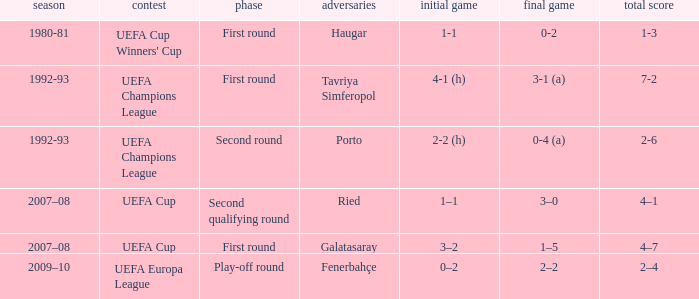 what's the competition where 1st leg is 4-1 (h) UEFA Champions League. 